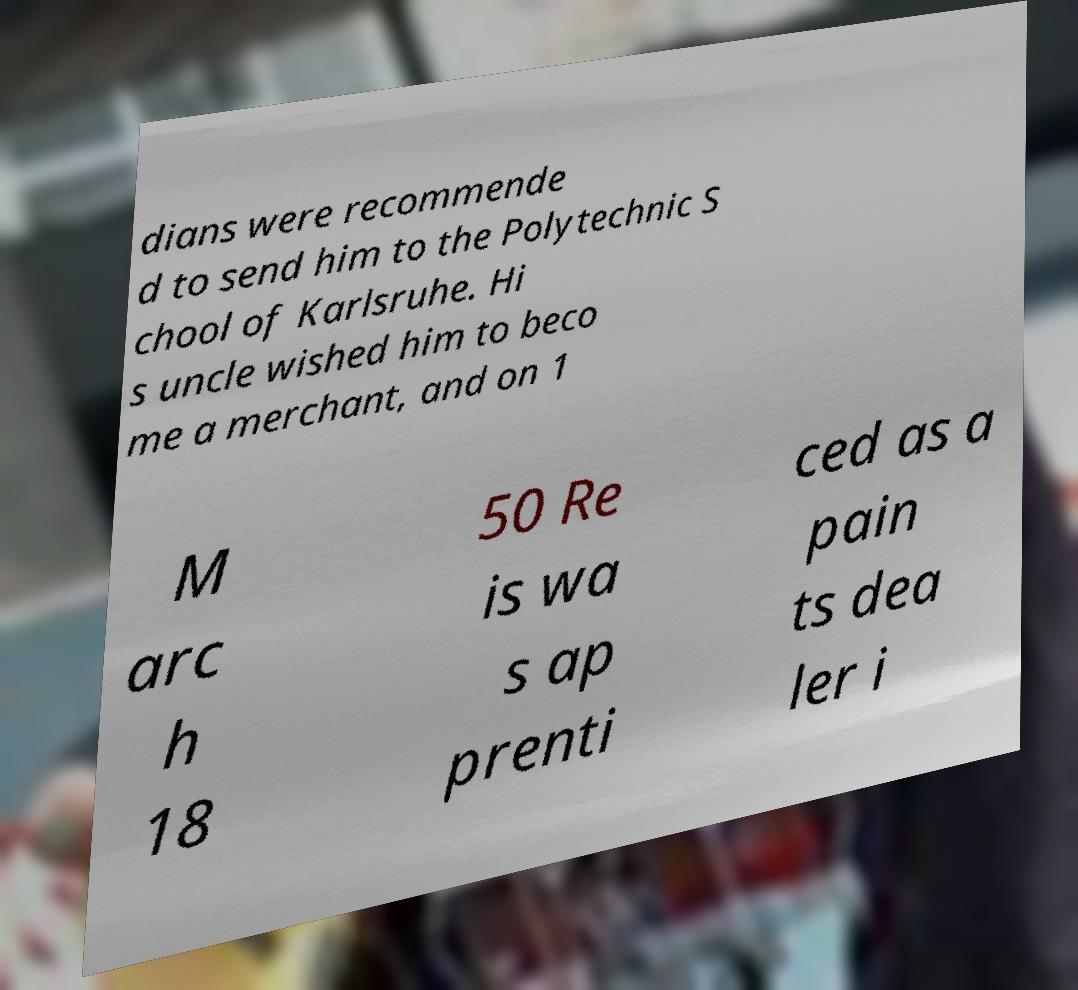Please read and relay the text visible in this image. What does it say? dians were recommende d to send him to the Polytechnic S chool of Karlsruhe. Hi s uncle wished him to beco me a merchant, and on 1 M arc h 18 50 Re is wa s ap prenti ced as a pain ts dea ler i 